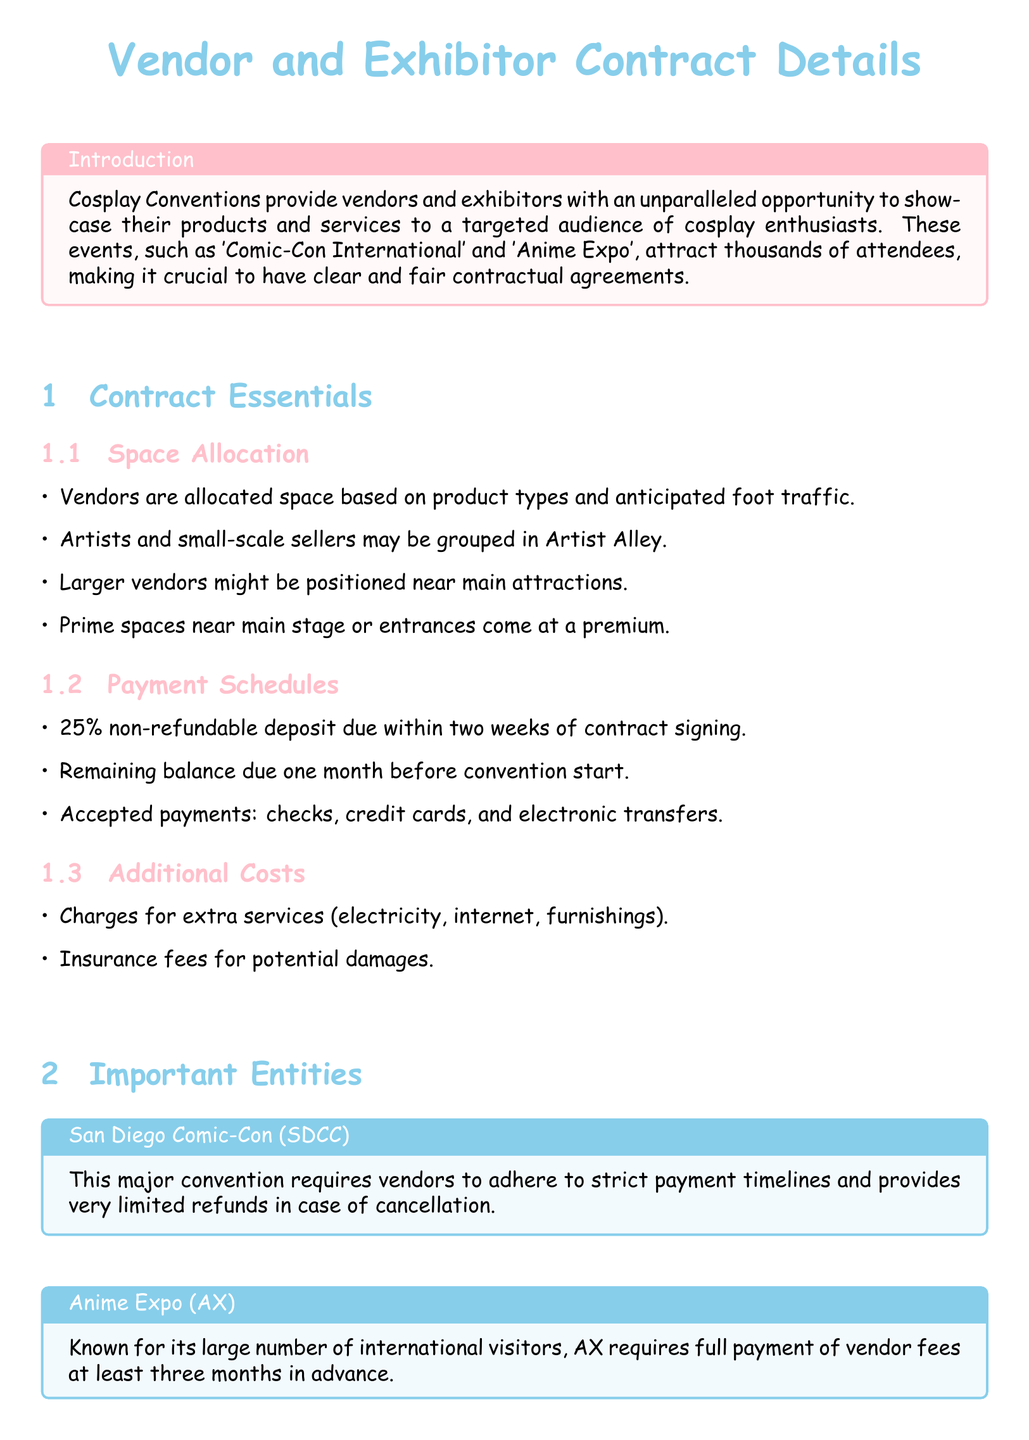What percentage is the non-refundable deposit? The document states that a 25% non-refundable deposit is due within two weeks of contract signing.
Answer: 25% What is the payment due date before the convention? The remaining balance payment is due one month before the convention starts.
Answer: One month What are the accepted payment methods? The document lists checks, credit cards, and electronic transfers as accepted payments.
Answer: Checks, credit cards, electronic transfers What type of vendors may be grouped in Artist Alley? The document mentions that artists and small-scale sellers may be grouped in Artist Alley.
Answer: Artists and small-scale sellers What does SDCC stand for? The abbreviation SDCC in the document stands for San Diego Comic-Con.
Answer: San Diego Comic-Con What is a potential additional cost mentioned in the document? The document identifies charges for extra services such as electricity, internet, and furnishings as additional costs.
Answer: Electricity, internet, furnishings When is full payment required by Anime Expo? The document specifies that Anime Expo requires full payment of vendor fees at least three months in advance.
Answer: Three months in advance What type of space do larger vendors get? The document states that larger vendors might be positioned near main attractions.
Answer: Near main attractions 